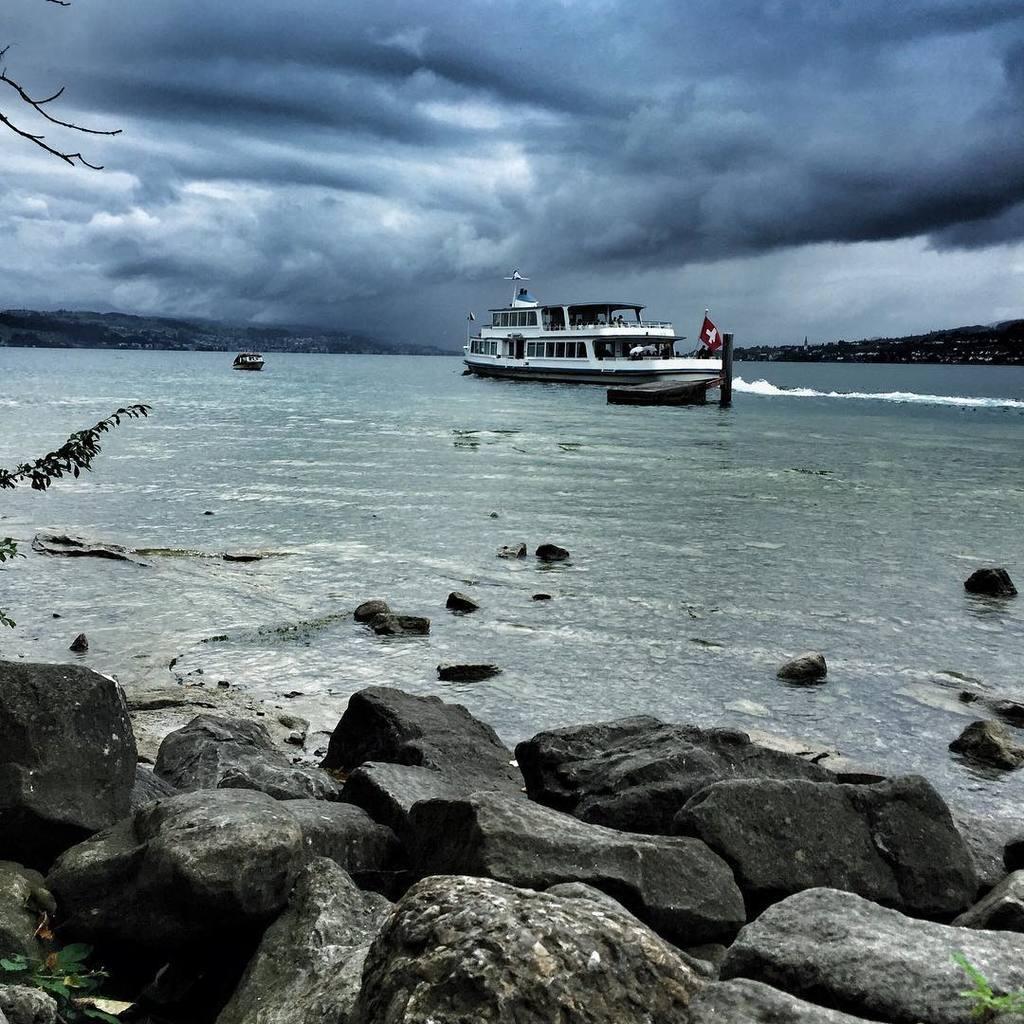Could you give a brief overview of what you see in this image? In this image we can see some ships in a large water body. We can also see the flag on a ship, some branches of a tree, some stones, the hills and the sky which looks cloudy. 